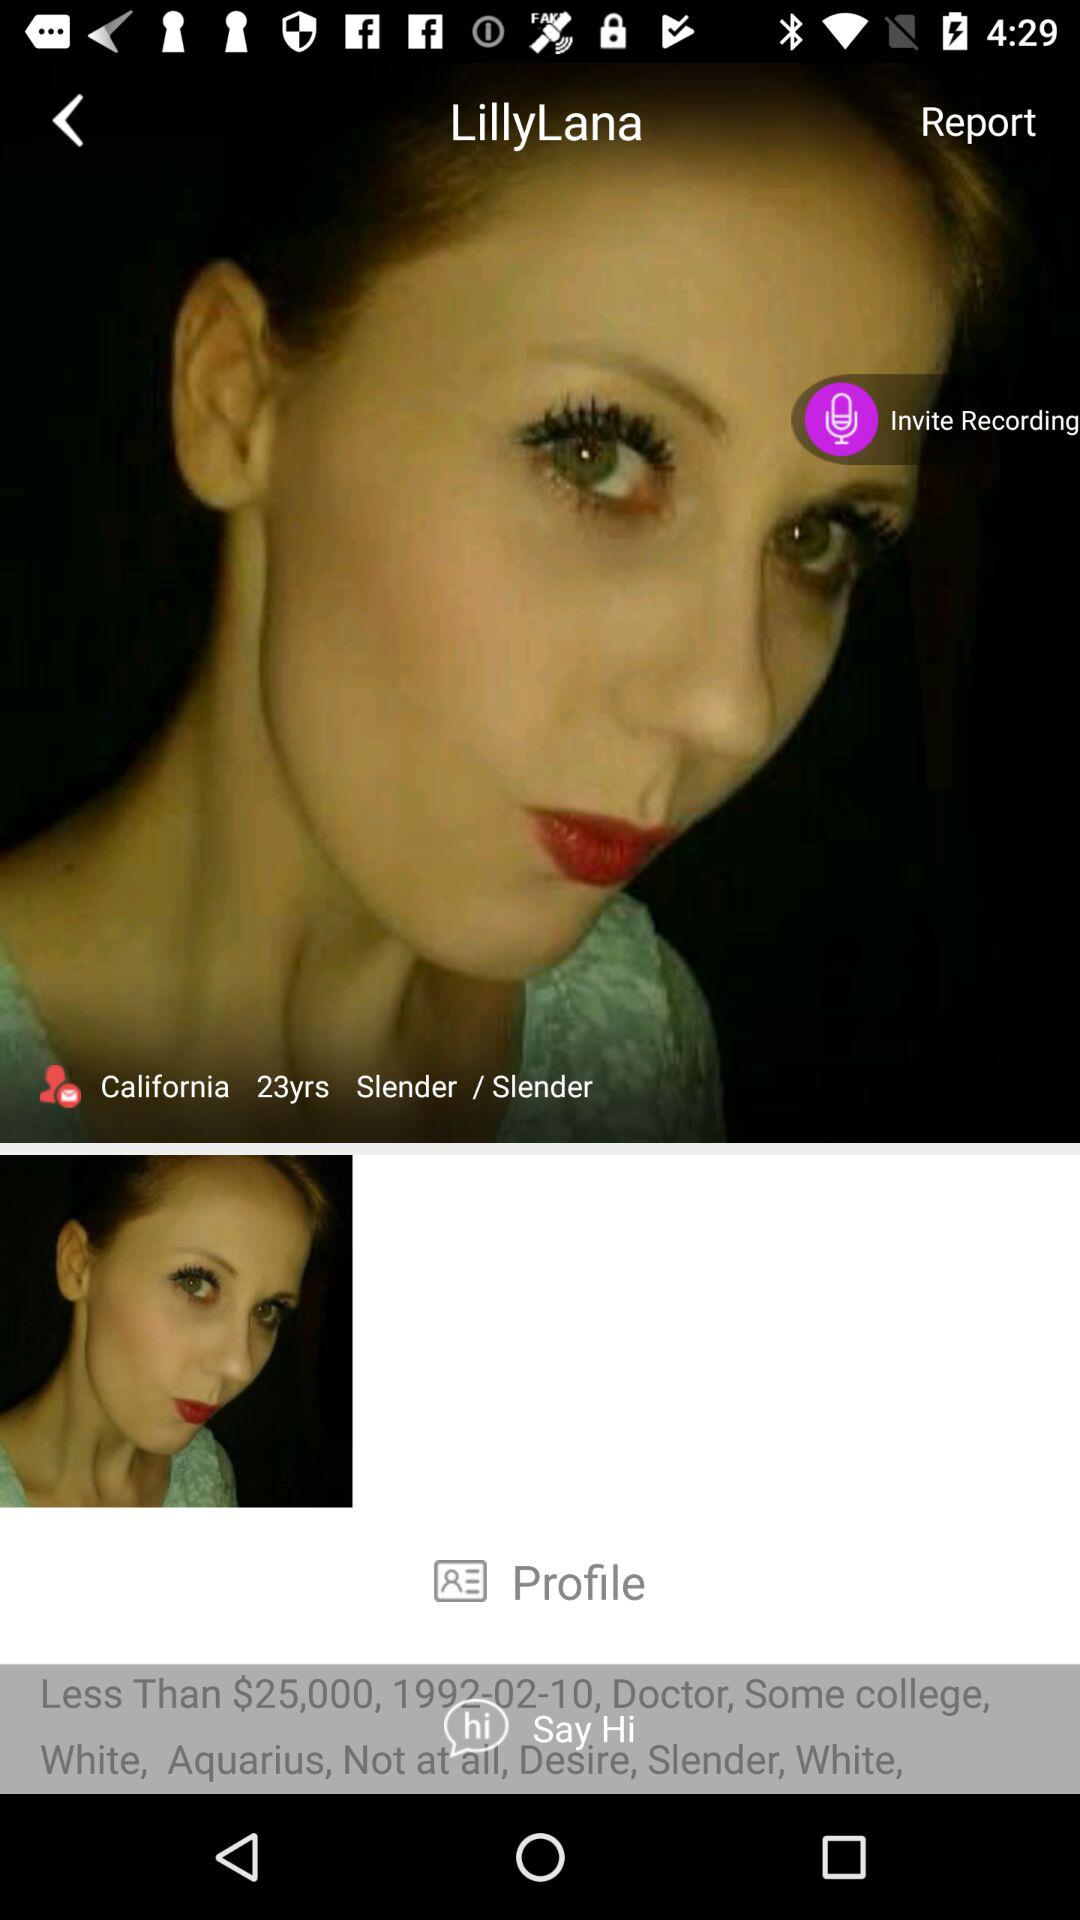What's the username? The username is "LillyLana". 